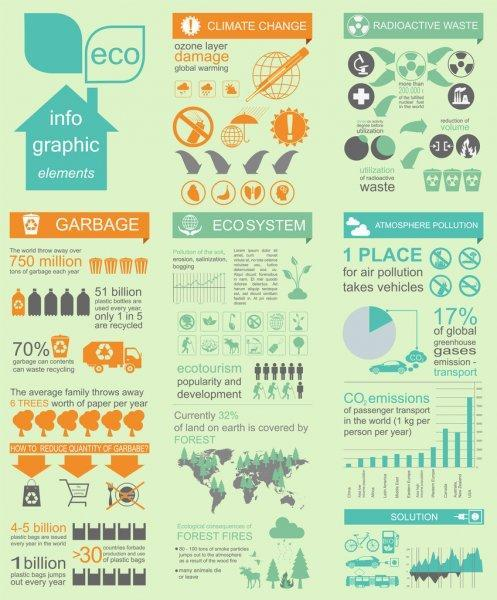What is the percentage of atmospheric pollution caused by vehicles?
Answer the question with a short phrase. 17% 